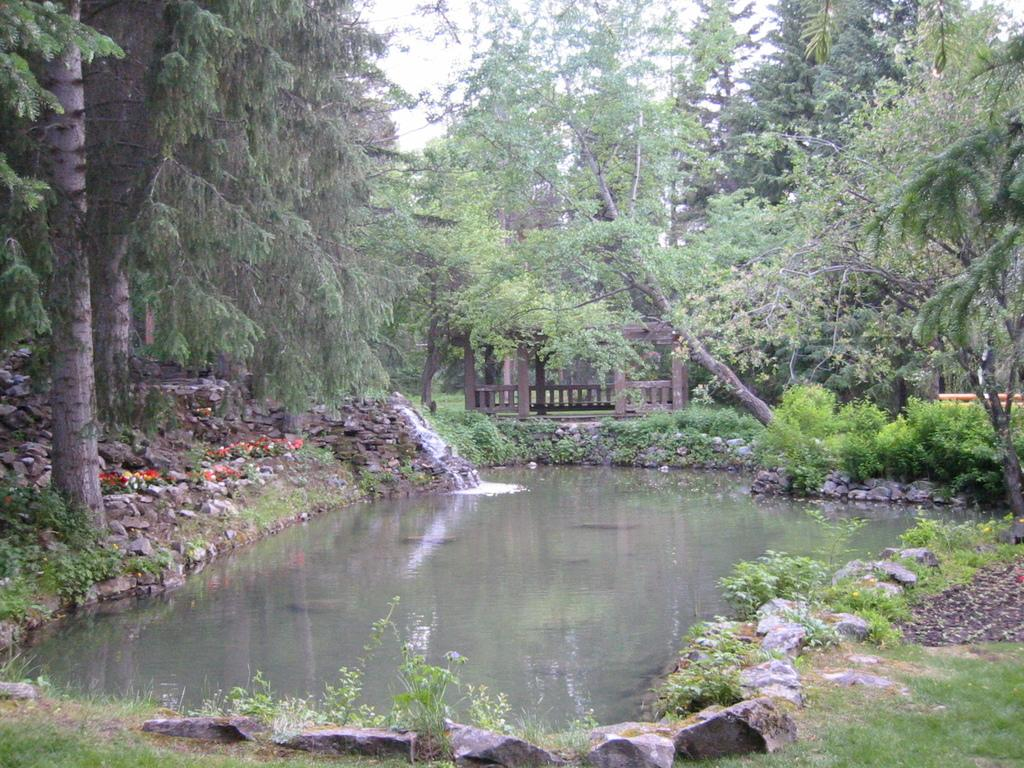What type of water feature is present in the image? There is a pond in the image. What surrounds the pond? Rocks are around the pond. What types of vegetation can be seen in the image? There are flowers, plants, bushes, and trees in the image. What is visible in the sky in the image? The sky is visible in the image. What type of structure is present in the image? There is a deck in the image. What committee is meeting on the deck in the image? There is no committee meeting on the deck in the image; it is a natural scene with a pond, rocks, and various types of vegetation. Can you see anyone running around the pond in the image? There is no one running around the pond in the image; it is a still scene with no visible human activity. 